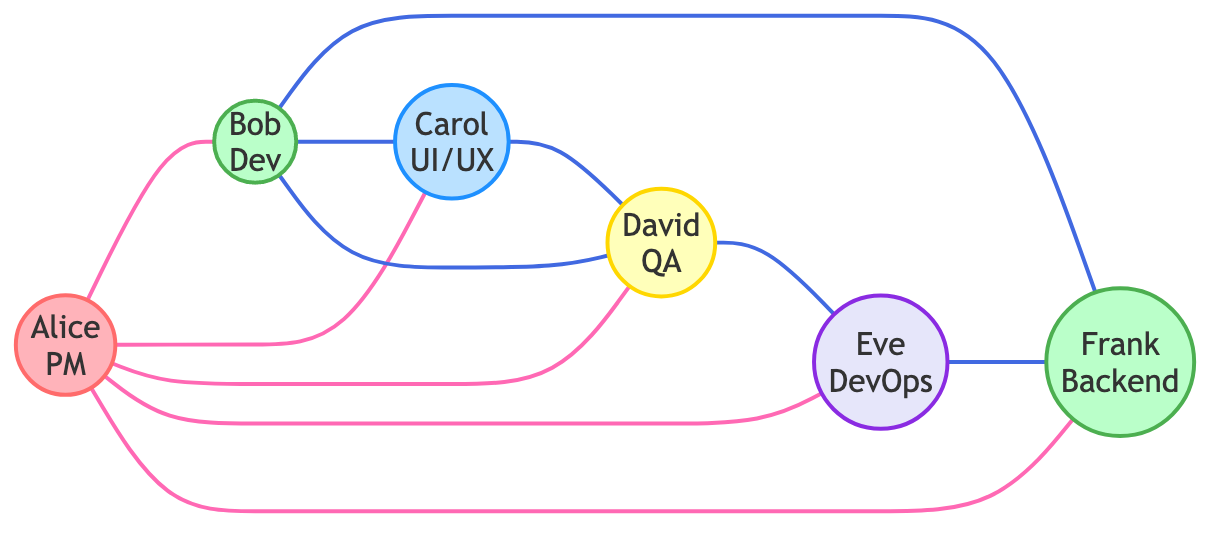What is the total number of nodes in the collaboration network? The diagram lists six distinct individuals (nodes): Alice, Bob, Carol, David, Eve, and Frank. Therefore, the total number of nodes is counted as six.
Answer: 6 Who coordinates with Bob? The diagram shows that Bob collaborates with several members, but specifically, Alice is indicated as coordinating directly with Bob. Thus, the person who coordinates with Bob is Alice.
Answer: Alice How many edges are there in total? Counting all connections (edges) shown in the diagram reveals eleven relationships established between the nodes. Thus, the total number of edges is eleven.
Answer: 11 Which role is associated with David? The diagram indicates that David holds the position of QA Engineer, which is explicitly stated next to his name. Hence, his associated role is QA Engineer.
Answer: QA Engineer Which two members discuss test cases? The diagram highlights a specific relationship where Bob and David are shown to discuss test cases. The direct connection indicates these two members engage in that activity.
Answer: Bob and David Who ensures continuous integration? The diagram specifies that Eve is the one who ensures continuous integration, directly connecting her with Frank in that capacity. This means that Eve is responsible for that task.
Answer: Eve What type of graph is this? The structure of the diagram, where connections are established without directed edges, classifies this graph as an undirected graph. Thus, the type of graph is undirected.
Answer: Undirected How many nodes are connected to Alice? By examining the diagram, we see Alice is connected to Bob, Carol, David, Eve, and Frank. Counting these connections yields a total of five nodes linked directly to Alice.
Answer: 5 Who collaborates with Frank? The diagram indicates that Bob and Eve have collaborative relationships with Frank, which means they work together with him on various aspects. Therefore, the members who collaborate with Frank are Bob and Eve.
Answer: Bob and Eve 